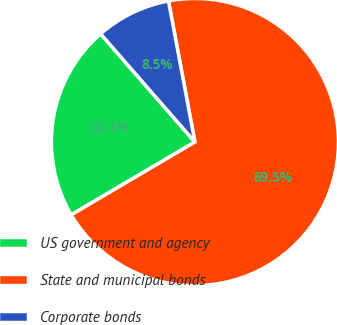Convert chart. <chart><loc_0><loc_0><loc_500><loc_500><pie_chart><fcel>US government and agency<fcel>State and municipal bonds<fcel>Corporate bonds<nl><fcel>22.06%<fcel>69.48%<fcel>8.46%<nl></chart> 